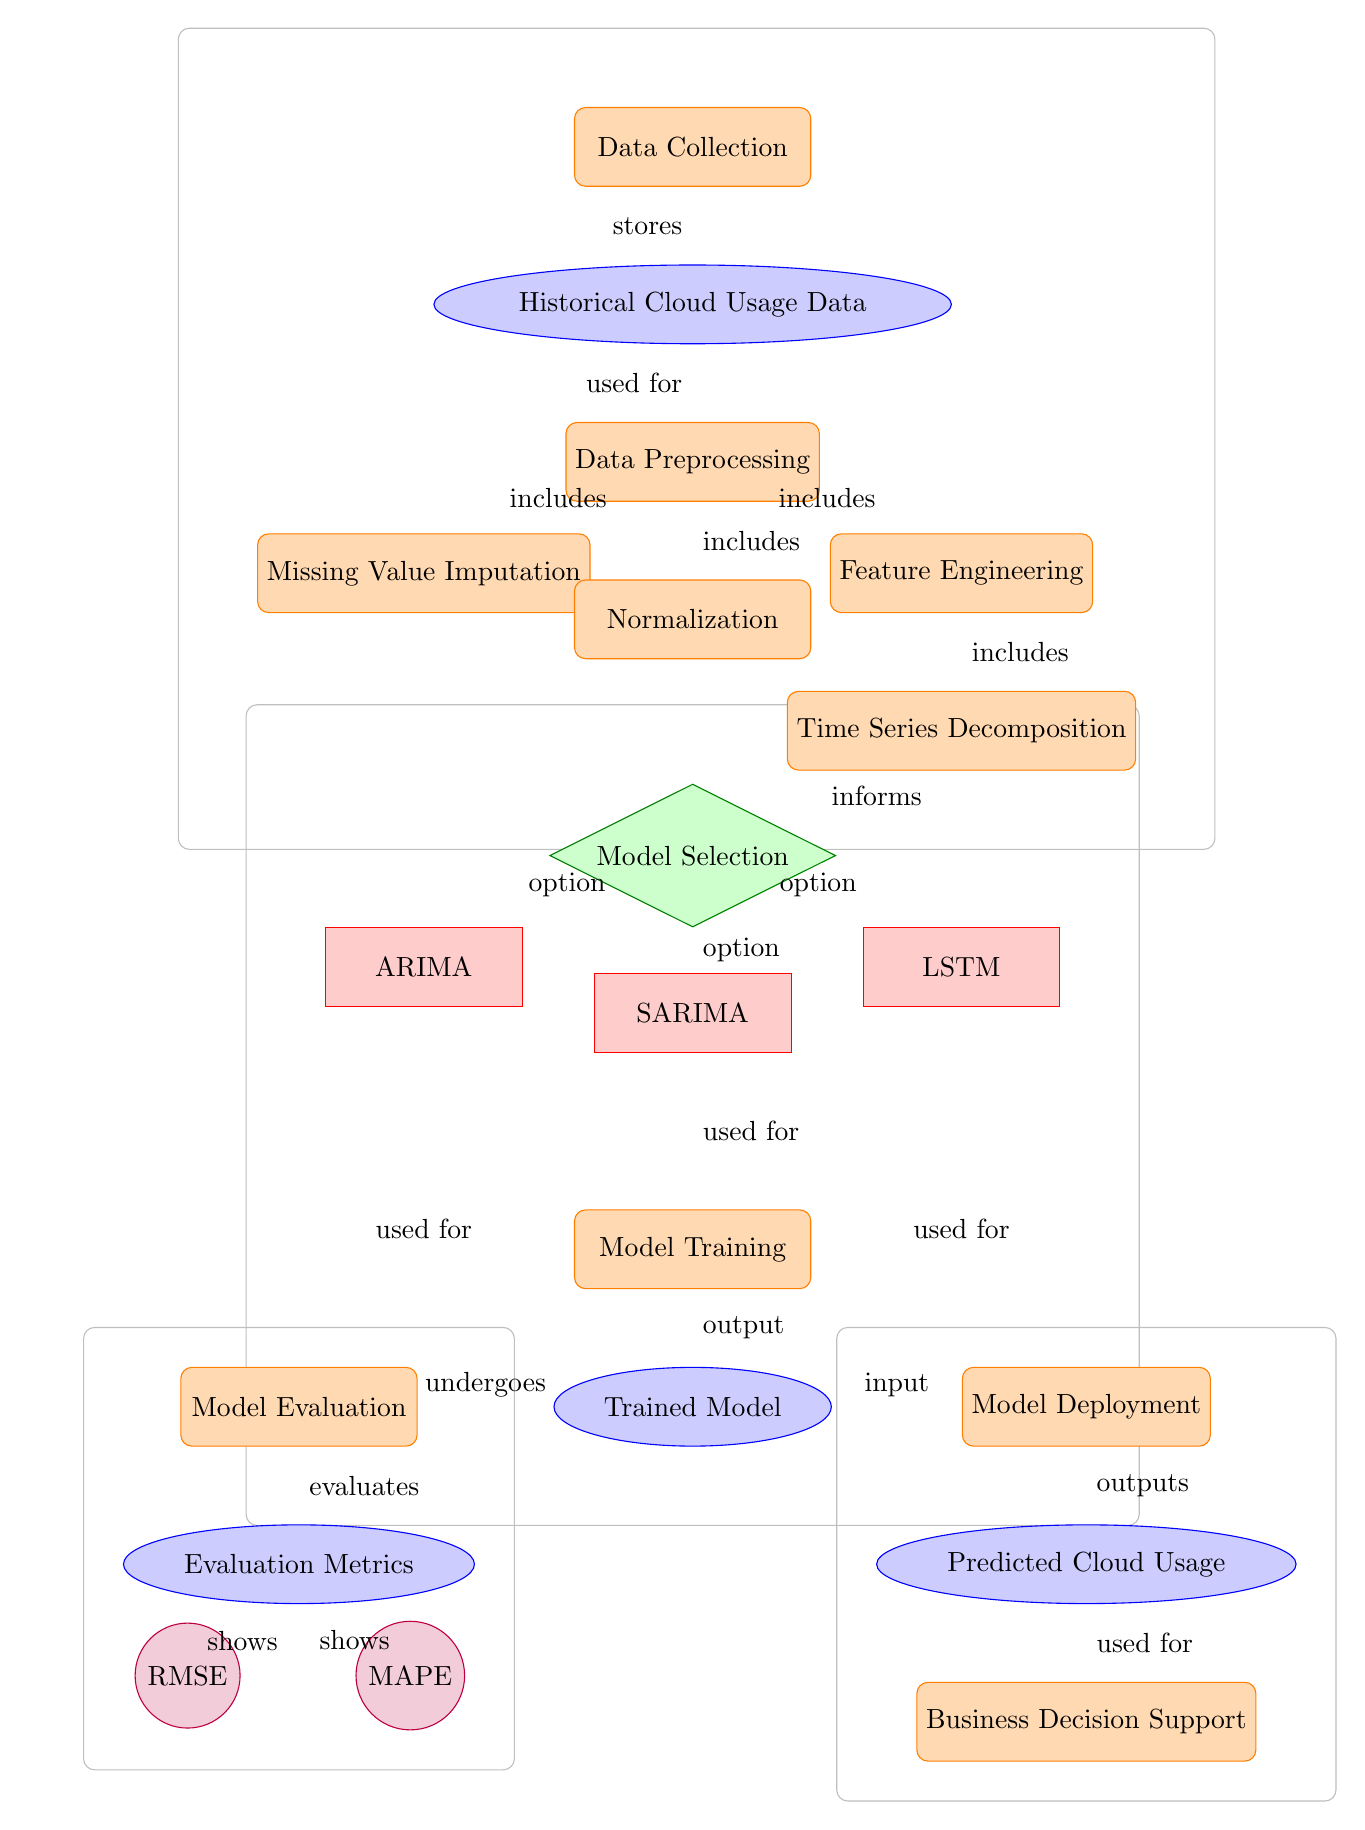What is the first step in the process? The first step in the process is indicated by the node labeled "Data Collection," which is positioned at the top of the diagram.
Answer: Data Collection How many models are selected during the Model Selection step? The Model Selection step leads to three options: ARIMA, SARIMA, and LSTM. Thus, there are three models selected.
Answer: 3 What follows after the Model Training step? The output of the Model Training step is the "Trained Model," which is shown directly below it in the diagram.
Answer: Trained Model Which metric is evaluated alongside RMSE? The diagram indicates that the RMSE is evaluated alongside the MAPE in the Evaluation Metrics node below the Model Evaluation step.
Answer: MAPE What is the output of the Model Deployment step? The output indicated in the diagram from the Model Deployment step is the "Predicted Cloud Usage," which is shown directly below it.
Answer: Predicted Cloud Usage What process follows after obtaining the Predicted Cloud Usage? According to the diagram, the process that follows is "Business Decision Support," which is indicated directly below the Predicted Cloud Usage node.
Answer: Business Decision Support Which process includes Normalization? Normalization is included in the Data Preprocessing step as indicated by the arrows that branch out from the Data Preprocessing node.
Answer: Data Preprocessing Which type of model is used as an option during Model Selection? The diagram shows three types of models used as options: ARIMA, SARIMA, and LSTM. They are grouped under the decision node labeled Model Selection.
Answer: ARIMA, SARIMA, LSTM What is the purpose of Time Series Decomposition in this diagram? Time Series Decomposition informs the Model Selection decision, as shown by the arrow leading from it to the Model Selection node, indicating its role in the overall flow.
Answer: Informs Model Selection 